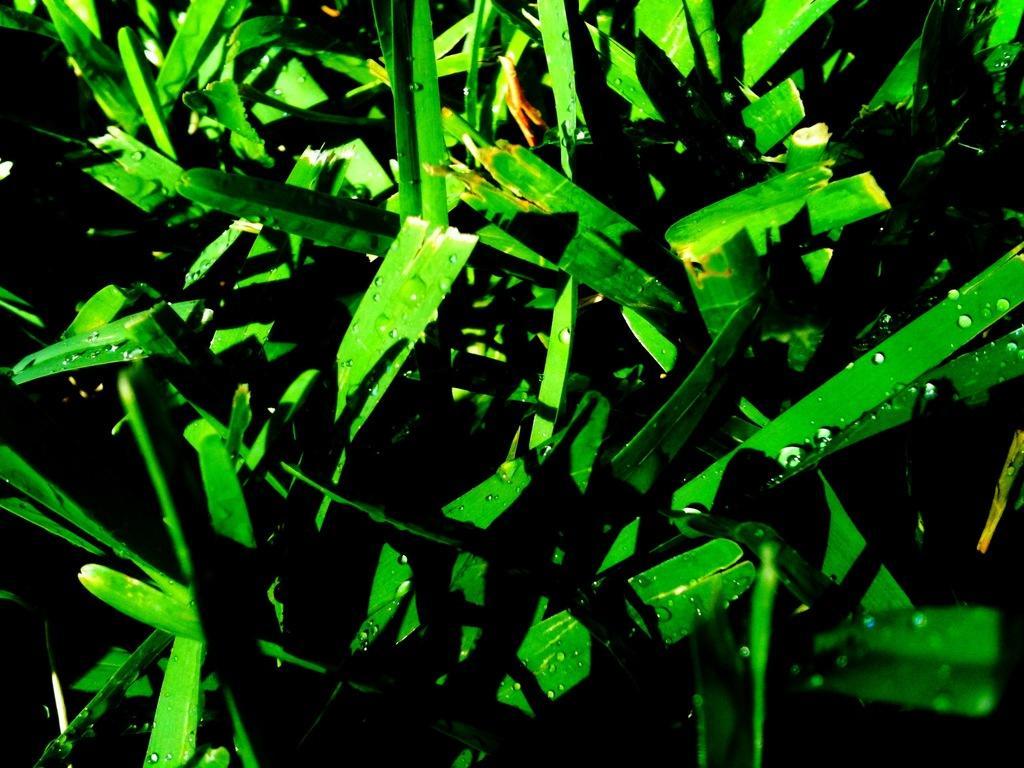In one or two sentences, can you explain what this image depicts? In this image, we can see some droplets on leafs. 